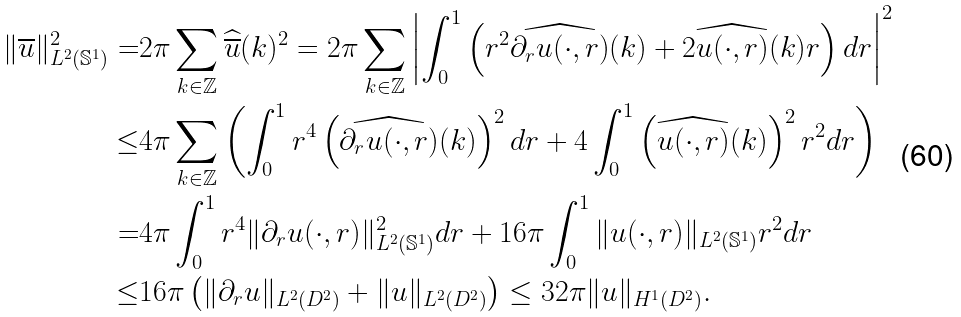Convert formula to latex. <formula><loc_0><loc_0><loc_500><loc_500>\| \overline { u } \| _ { L ^ { 2 } ( \mathbb { S } ^ { 1 } ) } ^ { 2 } = & 2 \pi \sum _ { k \in \mathbb { Z } } \widehat { \overline { u } } ( k ) ^ { 2 } = 2 \pi \sum _ { k \in \mathbb { Z } } \left | \int _ { 0 } ^ { 1 } \left ( r ^ { 2 } \widehat { \partial _ { r } u ( \cdot , r ) } ( k ) + 2 \widehat { u ( \cdot , r ) } ( k ) r \right ) d r \right | ^ { 2 } \\ \leq & 4 \pi \sum _ { k \in \mathbb { Z } } \left ( \int _ { 0 } ^ { 1 } r ^ { 4 } \left ( \widehat { \partial _ { r } u ( \cdot , r ) } ( k ) \right ) ^ { 2 } d r + 4 \int _ { 0 } ^ { 1 } \left ( \widehat { u ( \cdot , r ) } ( k ) \right ) ^ { 2 } r ^ { 2 } d r \right ) \\ = & 4 \pi \int _ { 0 } ^ { 1 } r ^ { 4 } \| \partial _ { r } u ( \cdot , r ) \| _ { L ^ { 2 } ( \mathbb { S } ^ { 1 } ) } ^ { 2 } d r + 1 6 \pi \int _ { 0 } ^ { 1 } \| u ( \cdot , r ) \| _ { L ^ { 2 } ( \mathbb { S } ^ { 1 } ) } r ^ { 2 } d r \\ \leq & 1 6 \pi \left ( \| \partial _ { r } u \| _ { L ^ { 2 } ( D ^ { 2 } ) } + \| u \| _ { L ^ { 2 } ( D ^ { 2 } ) } \right ) \leq 3 2 \pi \| u \| _ { H ^ { 1 } ( D ^ { 2 } ) } .</formula> 